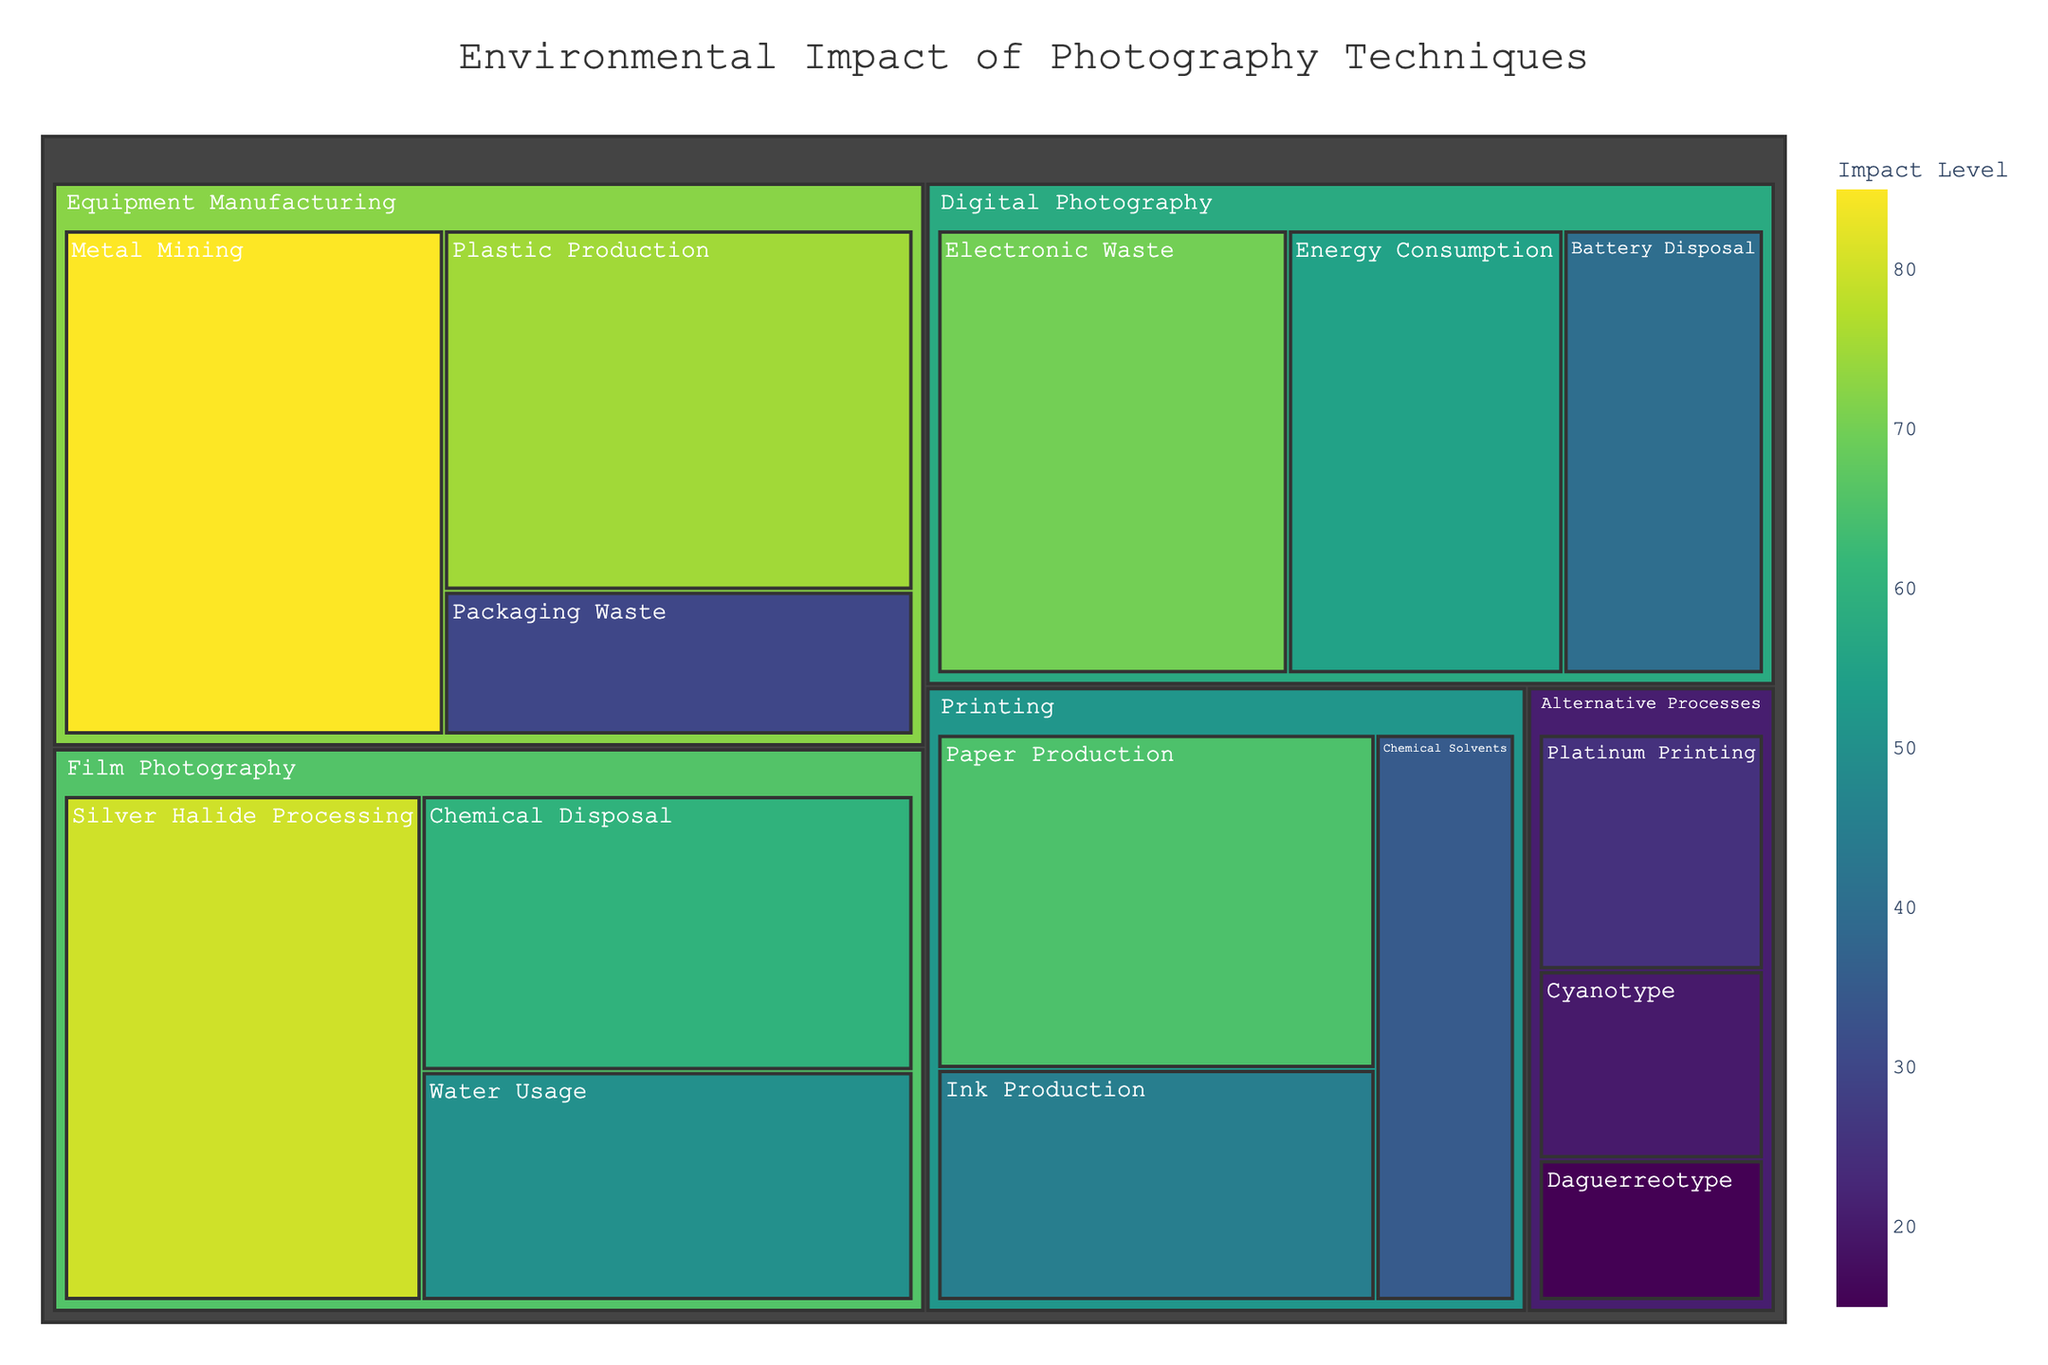What is the category with the highest environmental impact? By looking at the treemap, the category with the highest total impact can be determined by identifying the largest combined colored areas within a category.
Answer: Equipment Manufacturing Which subcategory has the lowest environmental impact? To find the subcategory with the lowest impact, look for the smallest individual box in the treemap.
Answer: Daguerreotype What is the total environmental impact of Film Photography? Add the impacts of all Film Photography subcategories: Silver Halide Processing (80), Chemical Disposal (60), and Water Usage (50). So, 80 + 60 + 50 = 190.
Answer: 190 Which subcategory in Digital Photography has greater impact, Energy Consumption or Electronic Waste? Compare the size and color of the boxes for Energy Consumption (55) and Electronic Waste (70) within Digital Photography.
Answer: Electronic Waste What is the average environmental impact of subcategories under Alternative Processes? Add the impacts of all subcategories under "Alternative Processes": Cyanotype (20), Platinum Printing (25), Daguerreotype (15). Total = 20 + 25 + 15 = 60; There are 3 subcategories, so 60 ÷ 3 = 20.
Answer: 20 Which category has the least environmental impact, printing or alternative processes? Compare the total impact values of Printing (45+65+35=145) and Alternative Processes (20+25+15=60).
Answer: Alternative Processes How does the impact of Metal Mining compare to Plastic Production under Equipment Manufacturing? Compare the values of Metal Mining (85) and Plastic Production (75) in the Equipment Manufacturing category.
Answer: Metal Mining has a higher impact Is the environmental impact of Battery Disposal in Digital Photography higher or lower than Cyanotype in Alternative Processes? Compare the values of Battery Disposal (40) in Digital Photography and Cyanotype (20) in Alternative Processes.
Answer: Higher What is the combined environmental impact of all Printing subcategories? Add the impacts of all subcategories under Printing: Ink Production (45), Paper Production (65), Chemical Solvents (35). So, 45 + 65 + 35 = 145.
Answer: 145 Which subcategory under Equipment Manufacturing has the least impact? Identify the smallest value subcategory under Equipment Manufacturing which is Packaging Waste (30).
Answer: Packaging Waste 